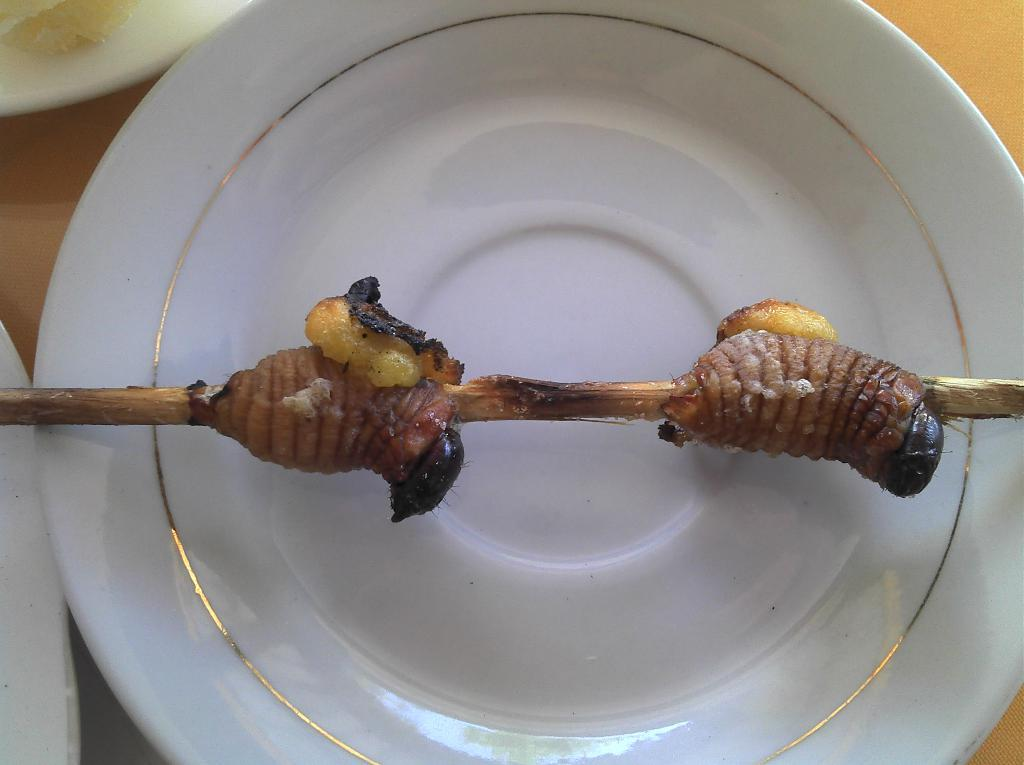What piece of furniture is present in the image? There is a table in the image. What is placed on the table? There are plates on the table. What else can be seen on the table besides plates? There is food placed on the table. Who is the servant attending to in the image? There is no servant present in the image. What type of skate is visible on the table? There is no skate present in the image. 